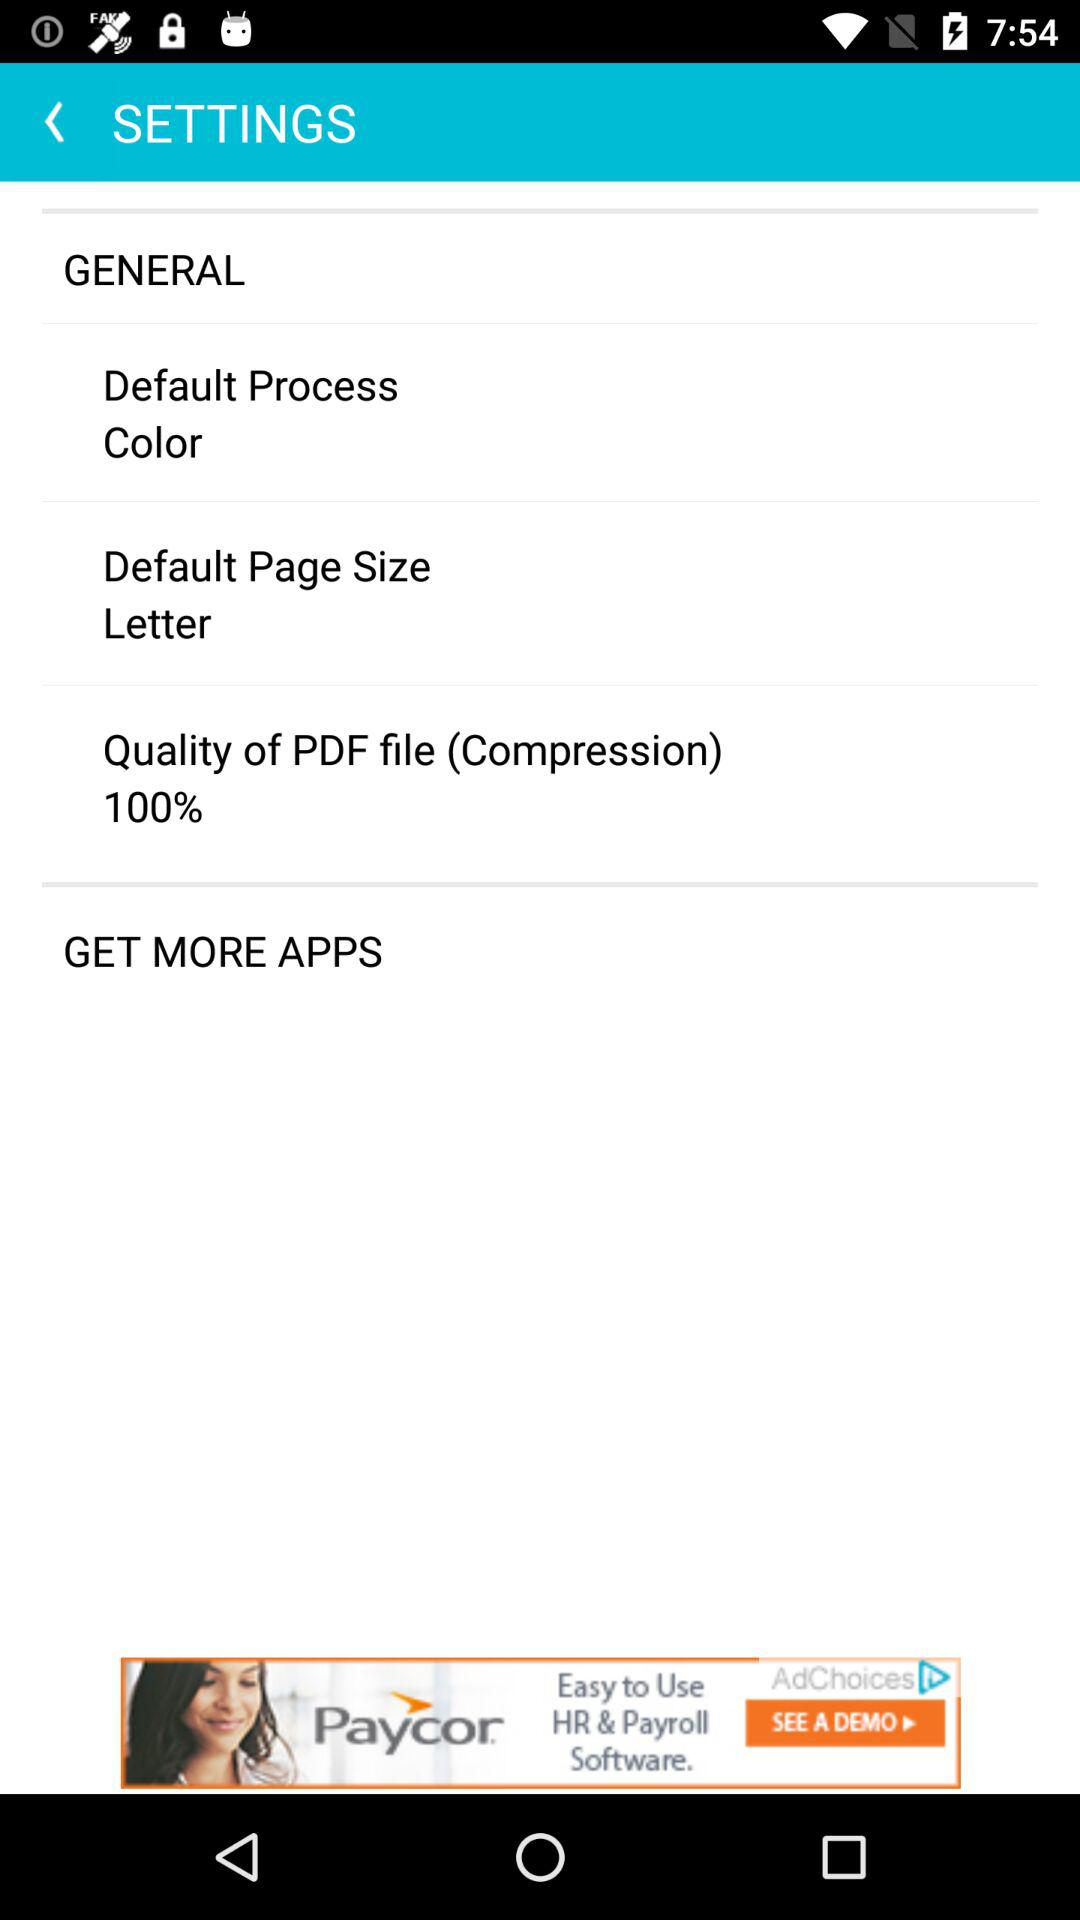What is the quality percentage of the PDF file? The quality percentage is 100. 